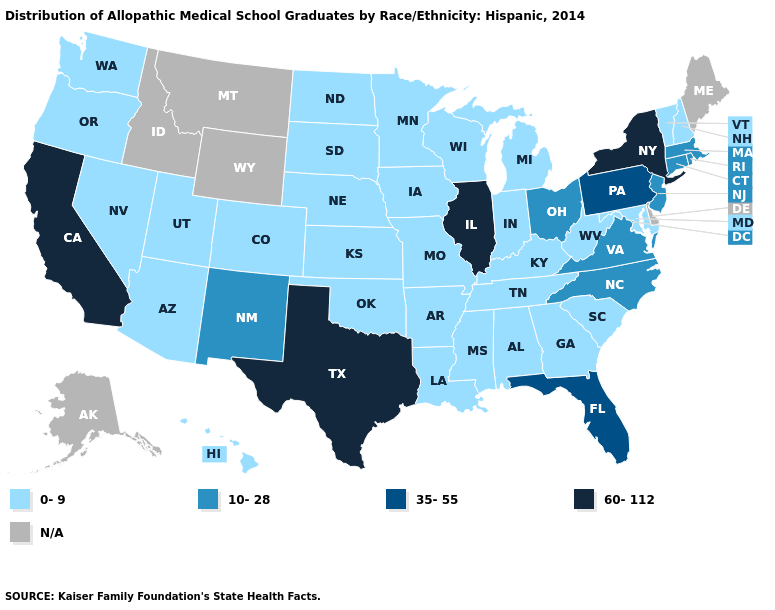Does Illinois have the highest value in the USA?
Be succinct. Yes. Name the states that have a value in the range 60-112?
Give a very brief answer. California, Illinois, New York, Texas. Which states hav the highest value in the West?
Keep it brief. California. What is the highest value in the MidWest ?
Quick response, please. 60-112. What is the value of Arkansas?
Quick response, please. 0-9. What is the value of New Mexico?
Write a very short answer. 10-28. What is the highest value in states that border Nevada?
Answer briefly. 60-112. Is the legend a continuous bar?
Give a very brief answer. No. Among the states that border New York , which have the highest value?
Write a very short answer. Pennsylvania. What is the value of Louisiana?
Keep it brief. 0-9. Does Georgia have the lowest value in the South?
Be succinct. Yes. What is the value of Connecticut?
Quick response, please. 10-28. Does the first symbol in the legend represent the smallest category?
Concise answer only. Yes. What is the value of Tennessee?
Be succinct. 0-9. 